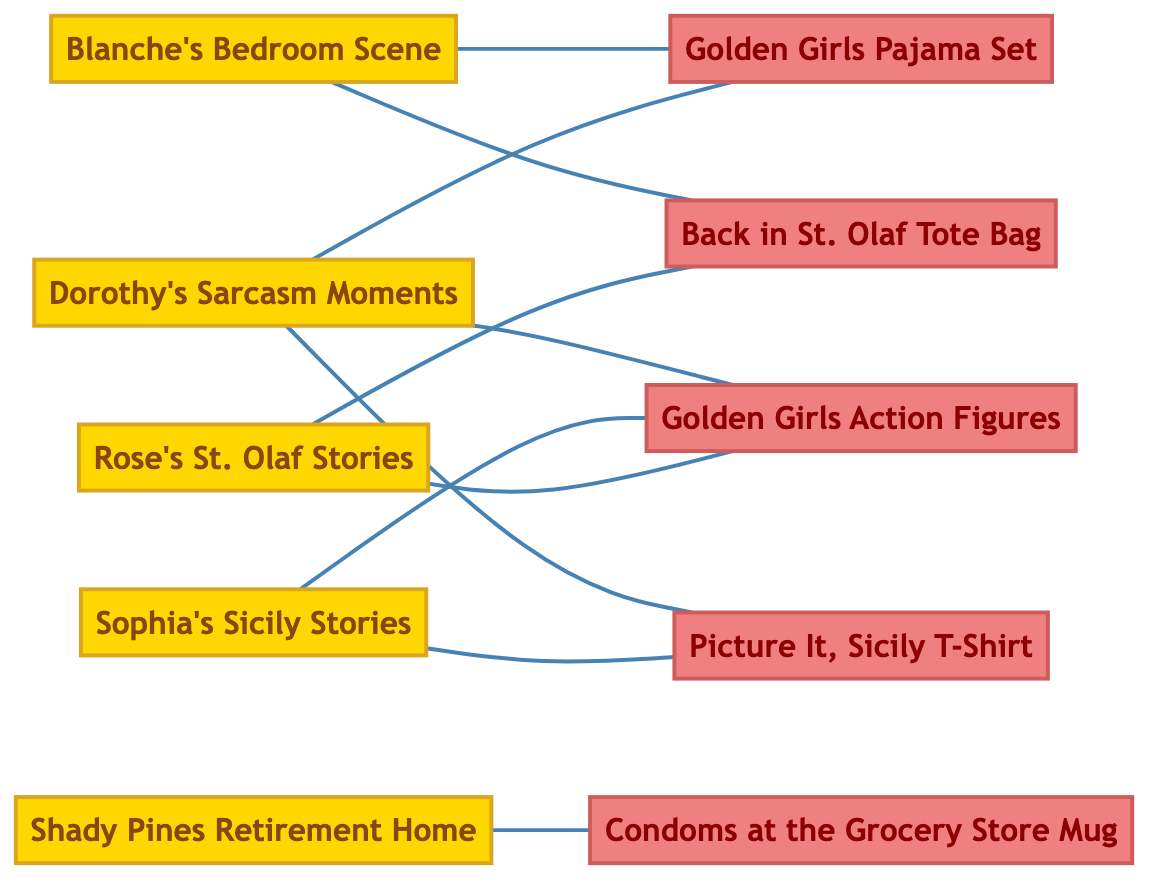What is the total number of iconic scenes in the diagram? The diagram lists five nodes categorized as "Iconic Scenes": Blanche's Bedroom Scene, Dorothy's Sarcasm Moments, Sophia's Sicily Stories, Rose's St. Olaf Stories, and Shady Pines Retirement Home. Therefore, the total number is 5.
Answer: 5 Which merchandise is connected to Blanche's Bedroom Scene? The diagram shows two links from Blanche's Bedroom Scene: one to Golden Girls Pajama Set and the other to Back in St. Olaf Tote Bag. Thus, the merchandise connected to it are these two items.
Answer: Golden Girls Pajama Set, Back in St. Olaf Tote Bag How many unique merchandise items are shown in the diagram? The diagram lists five merchandise items: Picture It, Sicily T-Shirt, Condoms at the Grocery Store Mug, Back in St. Olaf Tote Bag, Golden Girls Action Figures, and Golden Girls Pajama Set. So, there are 5 unique merchandise items in total.
Answer: 5 Which iconic scene has the most merchandise connections? When analyzing the connections, Dorothy's Sarcasm Moments links to three merchandise items: Golden Girls Action Figures, Golden Girls Pajama Set, and Picture It, Sicily T-Shirt, which is more than any other iconic scene. Therefore, it has the most connections.
Answer: Dorothy's Sarcasm Moments What are the two scenes connected to the Back in St. Olaf Tote Bag? The diagram indicates that the Back in St. Olaf Tote Bag is connected to two scenes: Rose's St. Olaf Stories and Blanche's Bedroom Scene. Thus, these are the two scenes connected to that merchandise.
Answer: Rose's St. Olaf Stories, Blanche's Bedroom Scene Which merchandise connects to Sophia's Sicily Stories? The diagram shows that Sophia's Sicily Stories links to two merchandise items: Picture It, Sicily T-Shirt and Golden Girls Action Figures. Therefore, both these items are connected to that iconic scene.
Answer: Picture It, Sicily T-Shirt, Golden Girls Action Figures Is there a connection between Shady Pines Retirement Home and merchandise? There is a connection displayed in the diagram from Shady Pines Retirement Home to Condoms at the Grocery Store Mug. This shows that there is indeed a merchandise item associated with it.
Answer: Yes What is the total number of edges in the diagram? By counting the connections displayed in the diagram, there are ten edges connecting the scenes to the merchandise. Hence, the total number of edges is 10.
Answer: 10 How many scenes are linked to Golden Girls Action Figures? The connections show that three iconic scenes are linked to the Golden Girls Action Figures: Dorothy's Sarcasm Moments, Sophia's Sicily Stories, and Rose's St. Olaf Stories. Therefore, the number of scenes linked is 3.
Answer: 3 